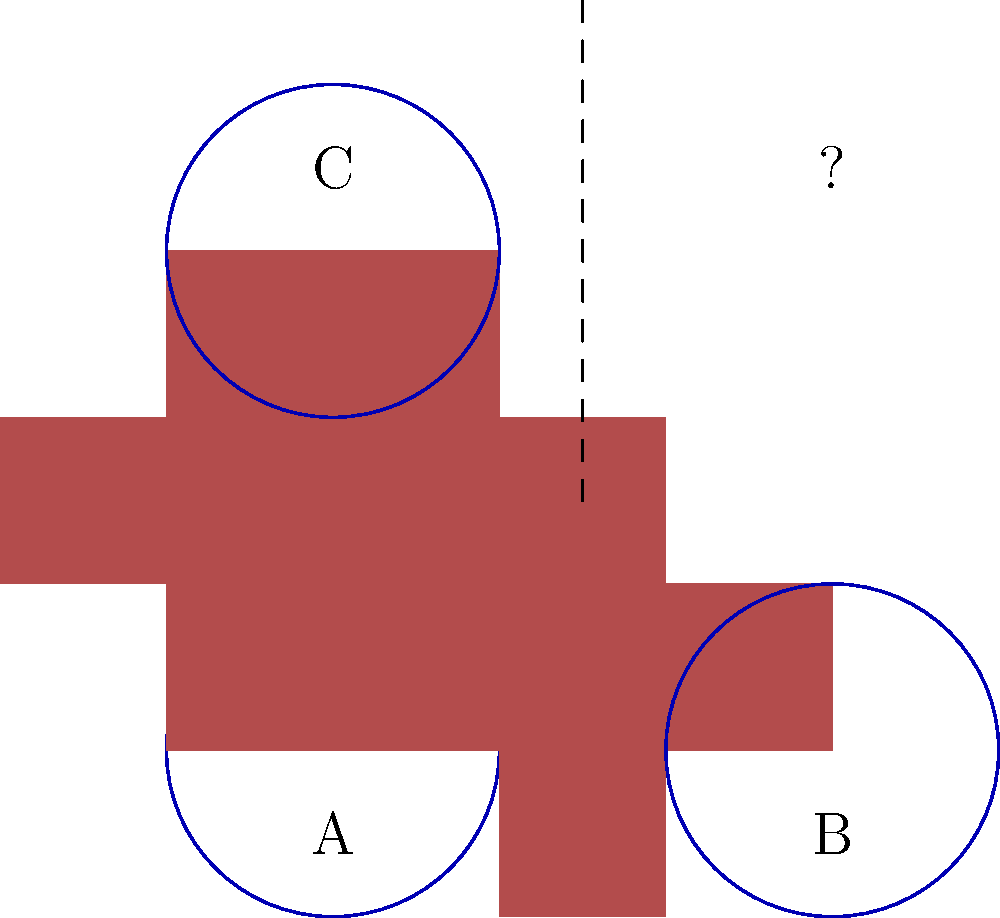In our chapel's stained glass window restoration project, we need to mentally rotate and align patterns. Given the arrangements of crosses and circles in positions A, B, and C, which pattern would logically fit in the empty space marked with a question mark? To solve this problem, let's follow these steps:

1. Observe the existing patterns:
   - Pattern A: Cross is upright, circle is centered.
   - Pattern B: Cross is rotated 90° clockwise from A.
   - Pattern C: Cross is rotated 180° from A (upside down).

2. Notice the relationship between patterns:
   - From A to B: 90° clockwise rotation
   - From A to C: 180° rotation (or flip)

3. Identify the pattern for the missing space:
   - It should complete the sequence logically.
   - The missing space is diagonally opposite to A.

4. Apply the transformation:
   - To get from A to the missing space, we need to rotate 270° clockwise (or 90° counterclockwise).
   - This is equivalent to rotating B by an additional 180°.

5. Visualize the result:
   - The cross will be rotated 270° from the upright position.
   - The circle remains centered, as rotation doesn't affect its appearance.

Therefore, the pattern in the missing space should be a cross rotated 270° clockwise from the upright position, with a centered circle.
Answer: Cross rotated 270° clockwise with centered circle 